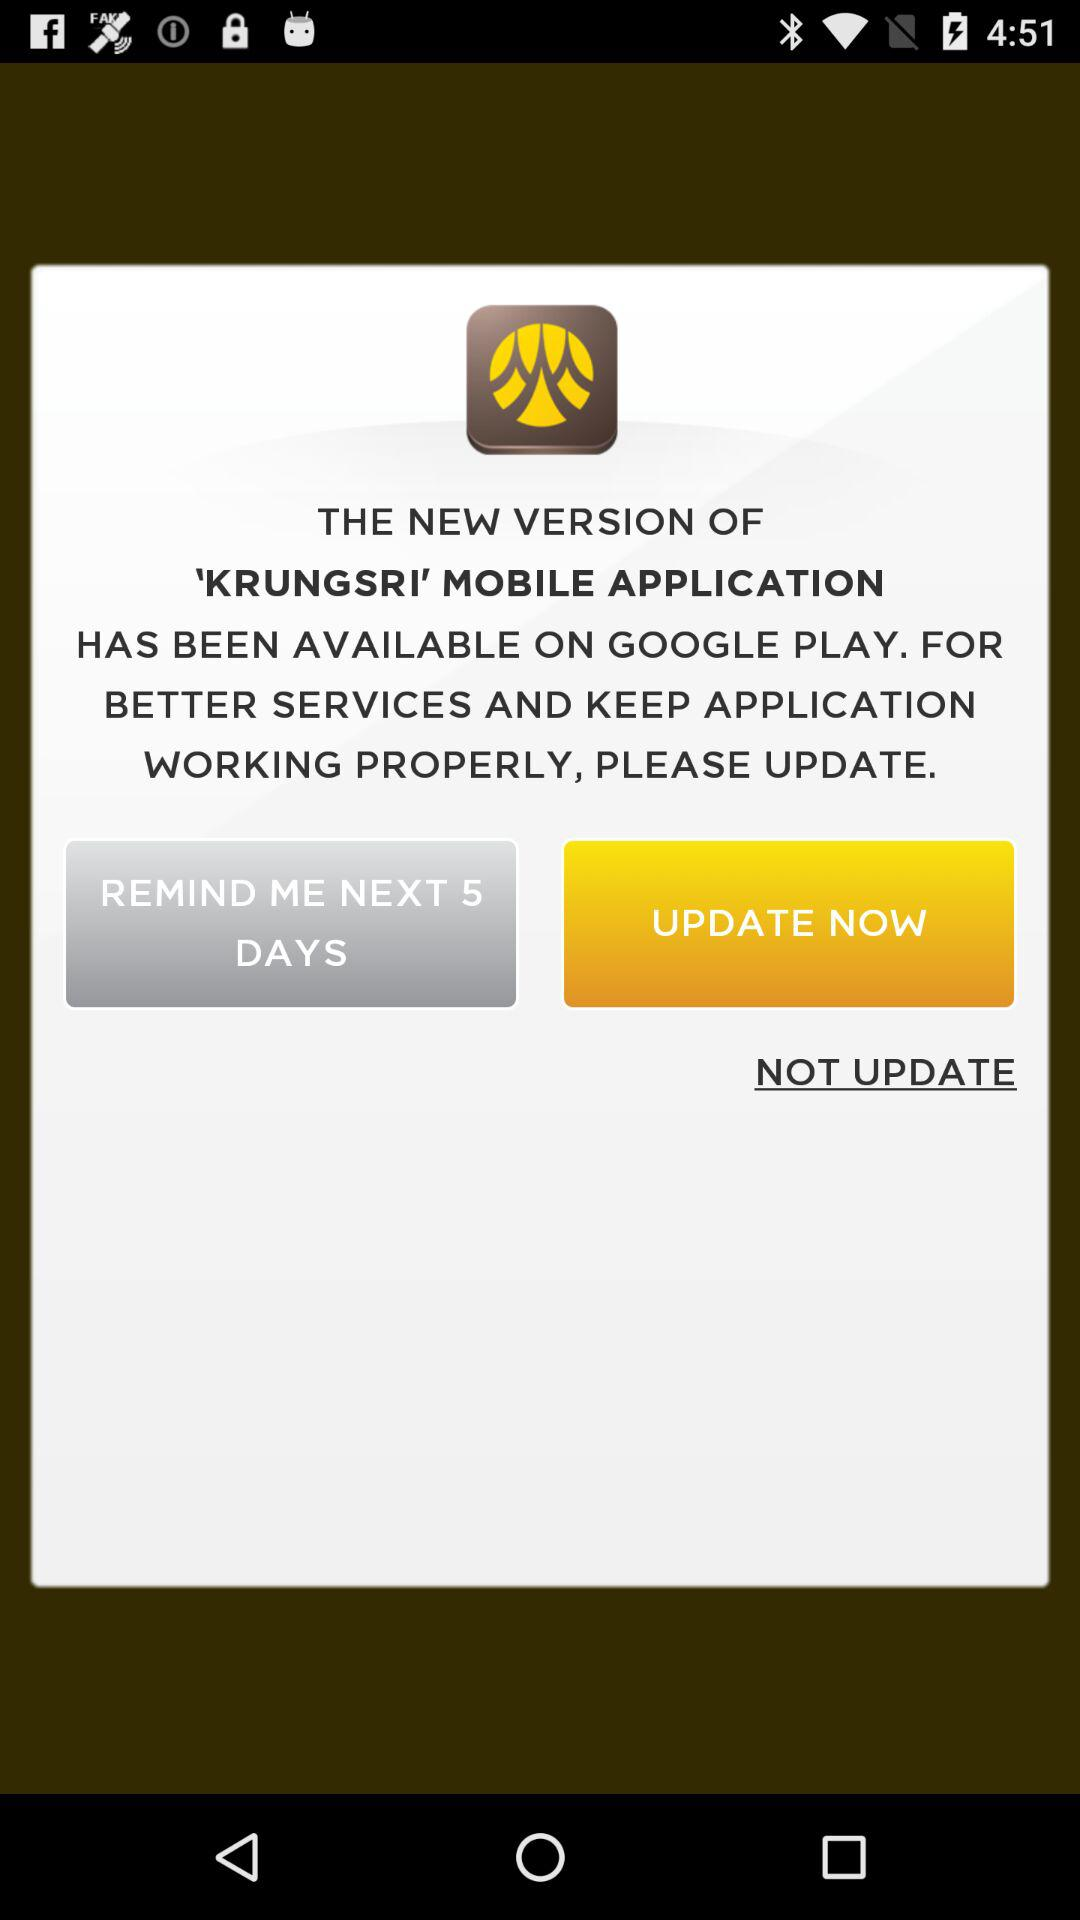What is the number of reminder days? The number of reminder days is 5. 